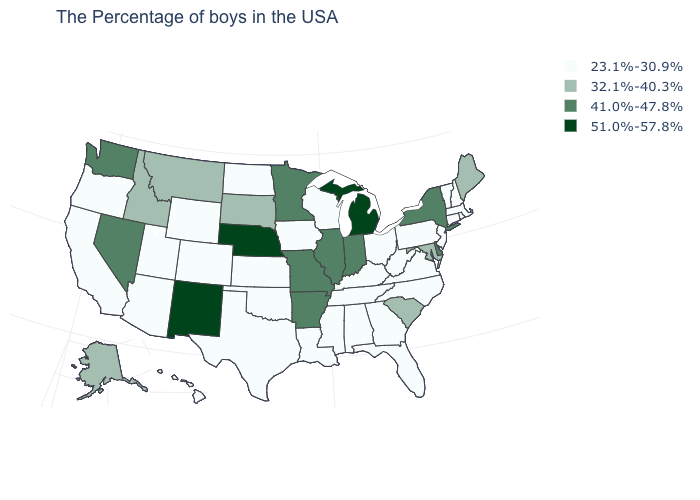What is the value of Oklahoma?
Be succinct. 23.1%-30.9%. How many symbols are there in the legend?
Give a very brief answer. 4. What is the value of New Hampshire?
Write a very short answer. 23.1%-30.9%. Name the states that have a value in the range 32.1%-40.3%?
Concise answer only. Maine, Maryland, South Carolina, South Dakota, Montana, Idaho, Alaska. Name the states that have a value in the range 51.0%-57.8%?
Concise answer only. Michigan, Nebraska, New Mexico. What is the lowest value in the Northeast?
Concise answer only. 23.1%-30.9%. Name the states that have a value in the range 32.1%-40.3%?
Answer briefly. Maine, Maryland, South Carolina, South Dakota, Montana, Idaho, Alaska. Name the states that have a value in the range 41.0%-47.8%?
Short answer required. New York, Delaware, Indiana, Illinois, Missouri, Arkansas, Minnesota, Nevada, Washington. Name the states that have a value in the range 51.0%-57.8%?
Short answer required. Michigan, Nebraska, New Mexico. Name the states that have a value in the range 51.0%-57.8%?
Answer briefly. Michigan, Nebraska, New Mexico. Which states have the lowest value in the Northeast?
Be succinct. Massachusetts, Rhode Island, New Hampshire, Vermont, Connecticut, New Jersey, Pennsylvania. What is the highest value in states that border Arkansas?
Write a very short answer. 41.0%-47.8%. What is the lowest value in states that border Nevada?
Keep it brief. 23.1%-30.9%. Does Tennessee have the lowest value in the USA?
Quick response, please. Yes. How many symbols are there in the legend?
Answer briefly. 4. 